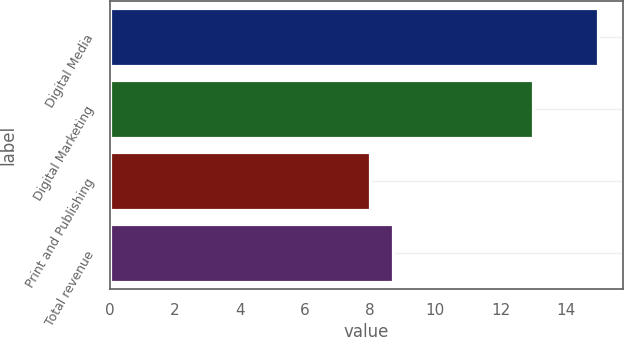Convert chart. <chart><loc_0><loc_0><loc_500><loc_500><bar_chart><fcel>Digital Media<fcel>Digital Marketing<fcel>Print and Publishing<fcel>Total revenue<nl><fcel>15<fcel>13<fcel>8<fcel>8.7<nl></chart> 